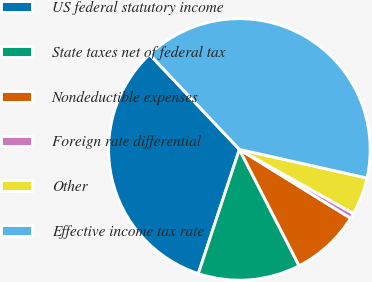<chart> <loc_0><loc_0><loc_500><loc_500><pie_chart><fcel>US federal statutory income<fcel>State taxes net of federal tax<fcel>Nondeductible expenses<fcel>Foreign rate differential<fcel>Other<fcel>Effective income tax rate<nl><fcel>32.86%<fcel>12.63%<fcel>8.64%<fcel>0.66%<fcel>4.65%<fcel>40.56%<nl></chart> 